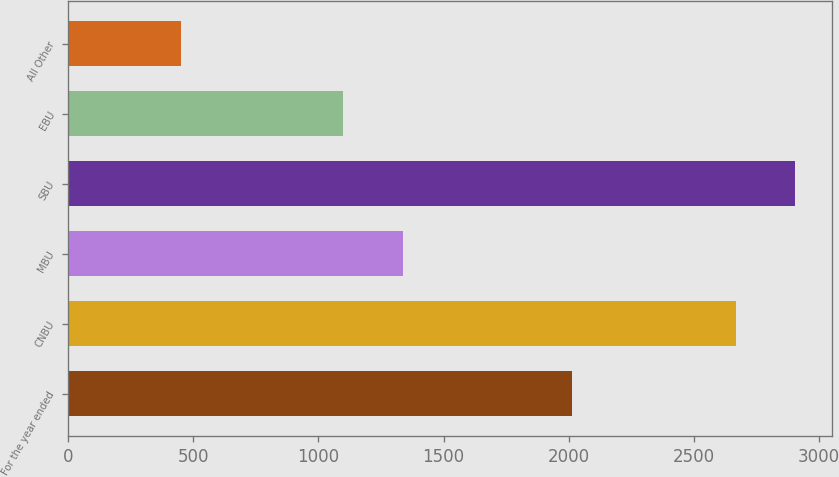<chart> <loc_0><loc_0><loc_500><loc_500><bar_chart><fcel>For the year ended<fcel>CNBU<fcel>MBU<fcel>SBU<fcel>EBU<fcel>All Other<nl><fcel>2012<fcel>2667<fcel>1336<fcel>2906<fcel>1097<fcel>452<nl></chart> 